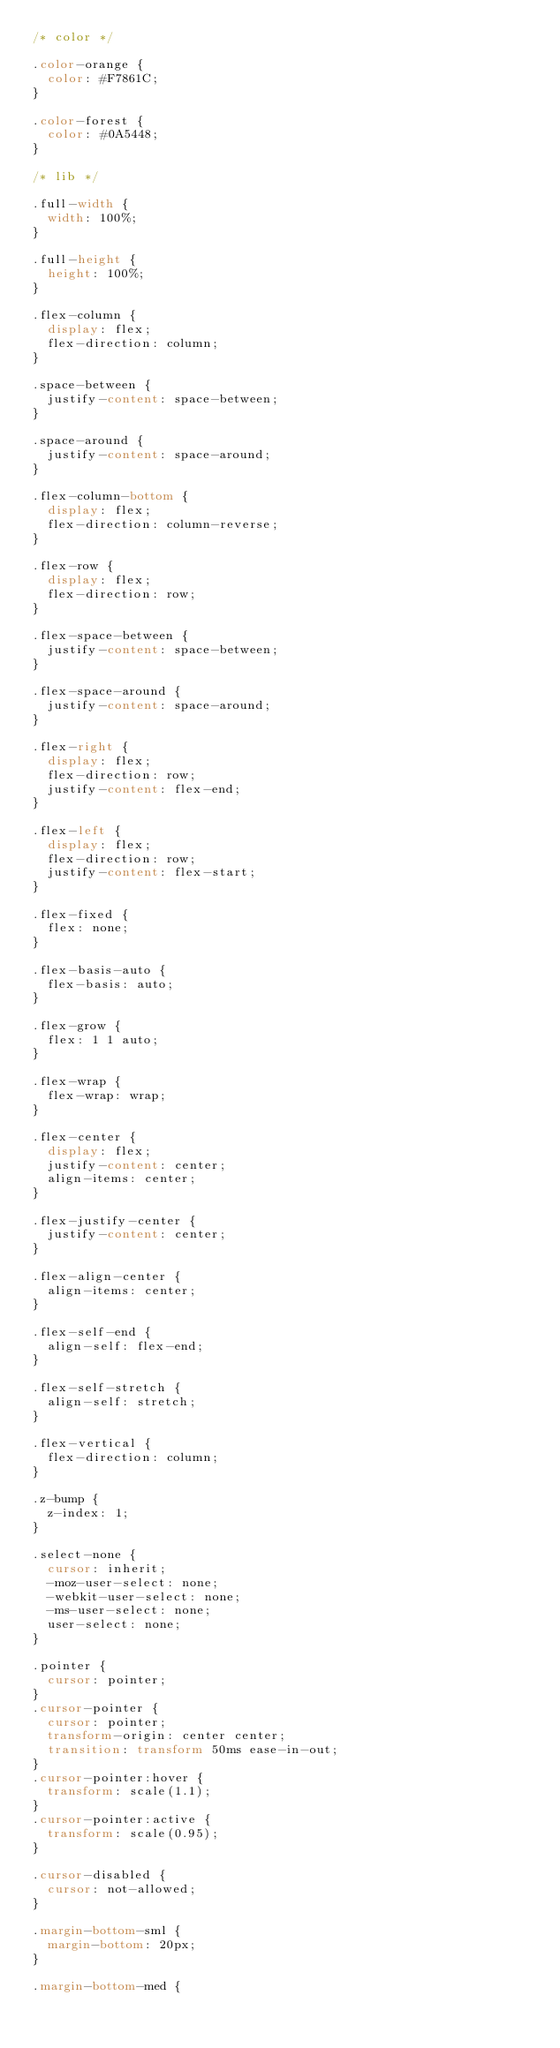<code> <loc_0><loc_0><loc_500><loc_500><_CSS_>/* color */

.color-orange {
  color: #F7861C;
}

.color-forest {
  color: #0A5448;
}

/* lib */

.full-width {
  width: 100%;
}

.full-height {
  height: 100%;
}

.flex-column {
  display: flex;
  flex-direction: column;
}

.space-between {
  justify-content: space-between;
}

.space-around {
  justify-content: space-around;
}

.flex-column-bottom {
  display: flex;
  flex-direction: column-reverse;
}

.flex-row {
  display: flex;
  flex-direction: row;
}

.flex-space-between {
  justify-content: space-between;
}

.flex-space-around {
  justify-content: space-around;
}

.flex-right {
  display: flex;
  flex-direction: row;
  justify-content: flex-end;
}

.flex-left {
  display: flex;
  flex-direction: row;
  justify-content: flex-start;
}

.flex-fixed {
  flex: none;
}

.flex-basis-auto {
  flex-basis: auto;
}

.flex-grow {
  flex: 1 1 auto;
}

.flex-wrap {
  flex-wrap: wrap;
}

.flex-center {
  display: flex;
  justify-content: center;
  align-items: center;
}

.flex-justify-center {
  justify-content: center;
}

.flex-align-center {
  align-items: center;
}

.flex-self-end {
  align-self: flex-end;
}

.flex-self-stretch {
  align-self: stretch;
}

.flex-vertical {
  flex-direction: column;
}

.z-bump {
  z-index: 1;
}

.select-none {
  cursor: inherit;
  -moz-user-select: none;
  -webkit-user-select: none;
  -ms-user-select: none;
  user-select: none;
}

.pointer {
  cursor: pointer;
}
.cursor-pointer {
  cursor: pointer;
  transform-origin: center center;
  transition: transform 50ms ease-in-out;
}
.cursor-pointer:hover {
  transform: scale(1.1);
}
.cursor-pointer:active {
  transform: scale(0.95);
}

.cursor-disabled {
  cursor: not-allowed;
}

.margin-bottom-sml {
  margin-bottom: 20px;
}

.margin-bottom-med {</code> 